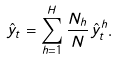<formula> <loc_0><loc_0><loc_500><loc_500>\hat { y } _ { t } = \sum _ { h = 1 } ^ { H } \frac { N _ { h } } { N } \hat { y } _ { t } ^ { h } .</formula> 